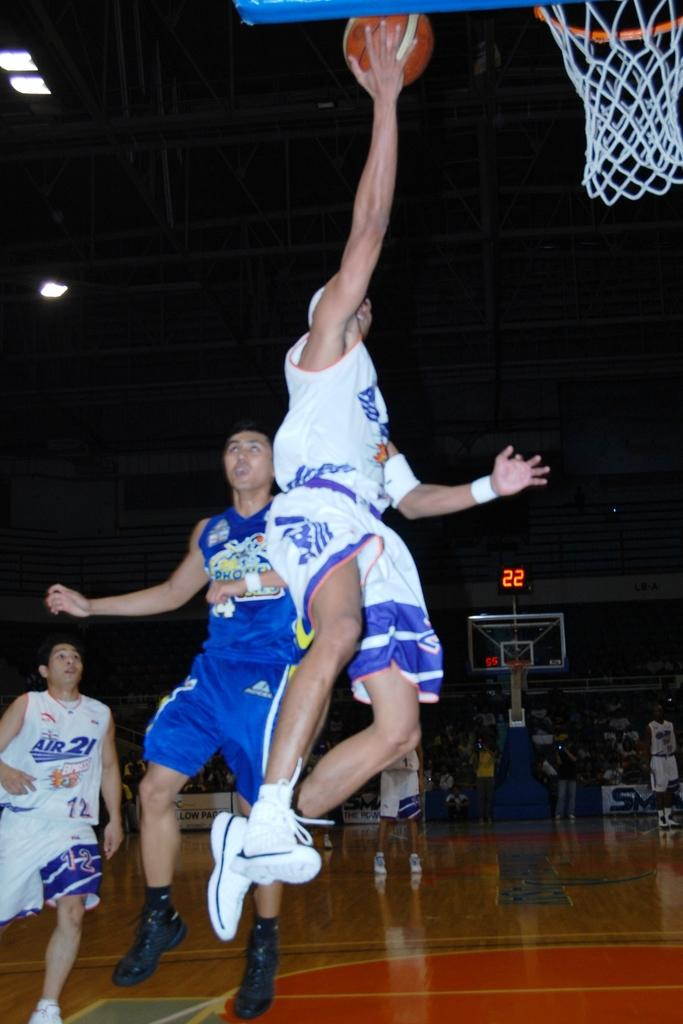<image>
Offer a succinct explanation of the picture presented. air player about to make a dunk basket while the score is at 22 